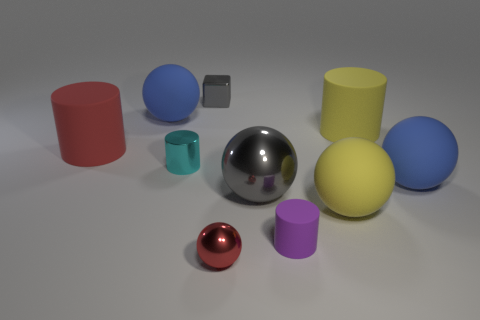There is a red thing that is behind the purple rubber cylinder; what shape is it?
Keep it short and to the point. Cylinder. How many other things are there of the same material as the cyan cylinder?
Give a very brief answer. 3. Is the color of the tiny ball the same as the tiny shiny block?
Ensure brevity in your answer.  No. Is the number of balls behind the yellow rubber sphere less than the number of small spheres that are left of the large red cylinder?
Your answer should be compact. No. What color is the other shiny thing that is the same shape as the big red object?
Offer a terse response. Cyan. There is a blue thing to the right of the purple rubber cylinder; is its size the same as the tiny cyan shiny object?
Provide a succinct answer. No. Is the number of small blocks that are to the right of the small matte thing less than the number of large purple metallic cylinders?
Your response must be concise. No. Are there any other things that have the same size as the block?
Give a very brief answer. Yes. How big is the blue matte thing behind the large cylinder to the right of the purple thing?
Your answer should be very brief. Large. Are there any other things that have the same shape as the tiny red metallic object?
Offer a very short reply. Yes. 